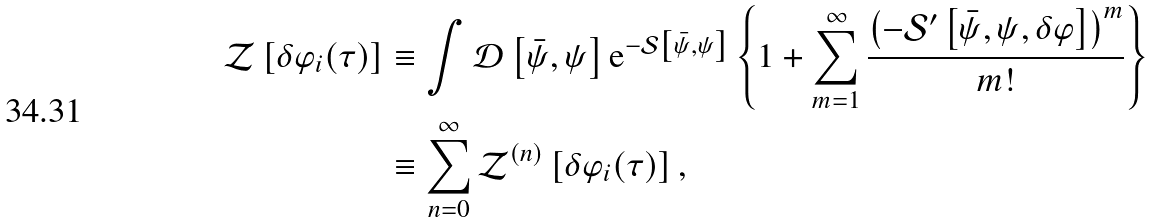<formula> <loc_0><loc_0><loc_500><loc_500>\mathcal { Z } \left [ \delta \varphi _ { i } ( \tau ) \right ] & \equiv \int \mathcal { D } \left [ \bar { \psi } , \psi \right ] \text {e} ^ { - \mathcal { S } \left [ \bar { \psi } , \psi \right ] } \left \{ 1 + \sum _ { m = 1 } ^ { \infty } \frac { \left ( - \mathcal { S } ^ { \prime } \left [ \bar { \psi } , \psi , \delta \varphi \right ] \right ) ^ { m } } { m ! } \right \} \\ & \equiv \sum _ { n = 0 } ^ { \infty } \mathcal { Z } ^ { ( n ) } \left [ \delta \varphi _ { i } ( \tau ) \right ] ,</formula> 